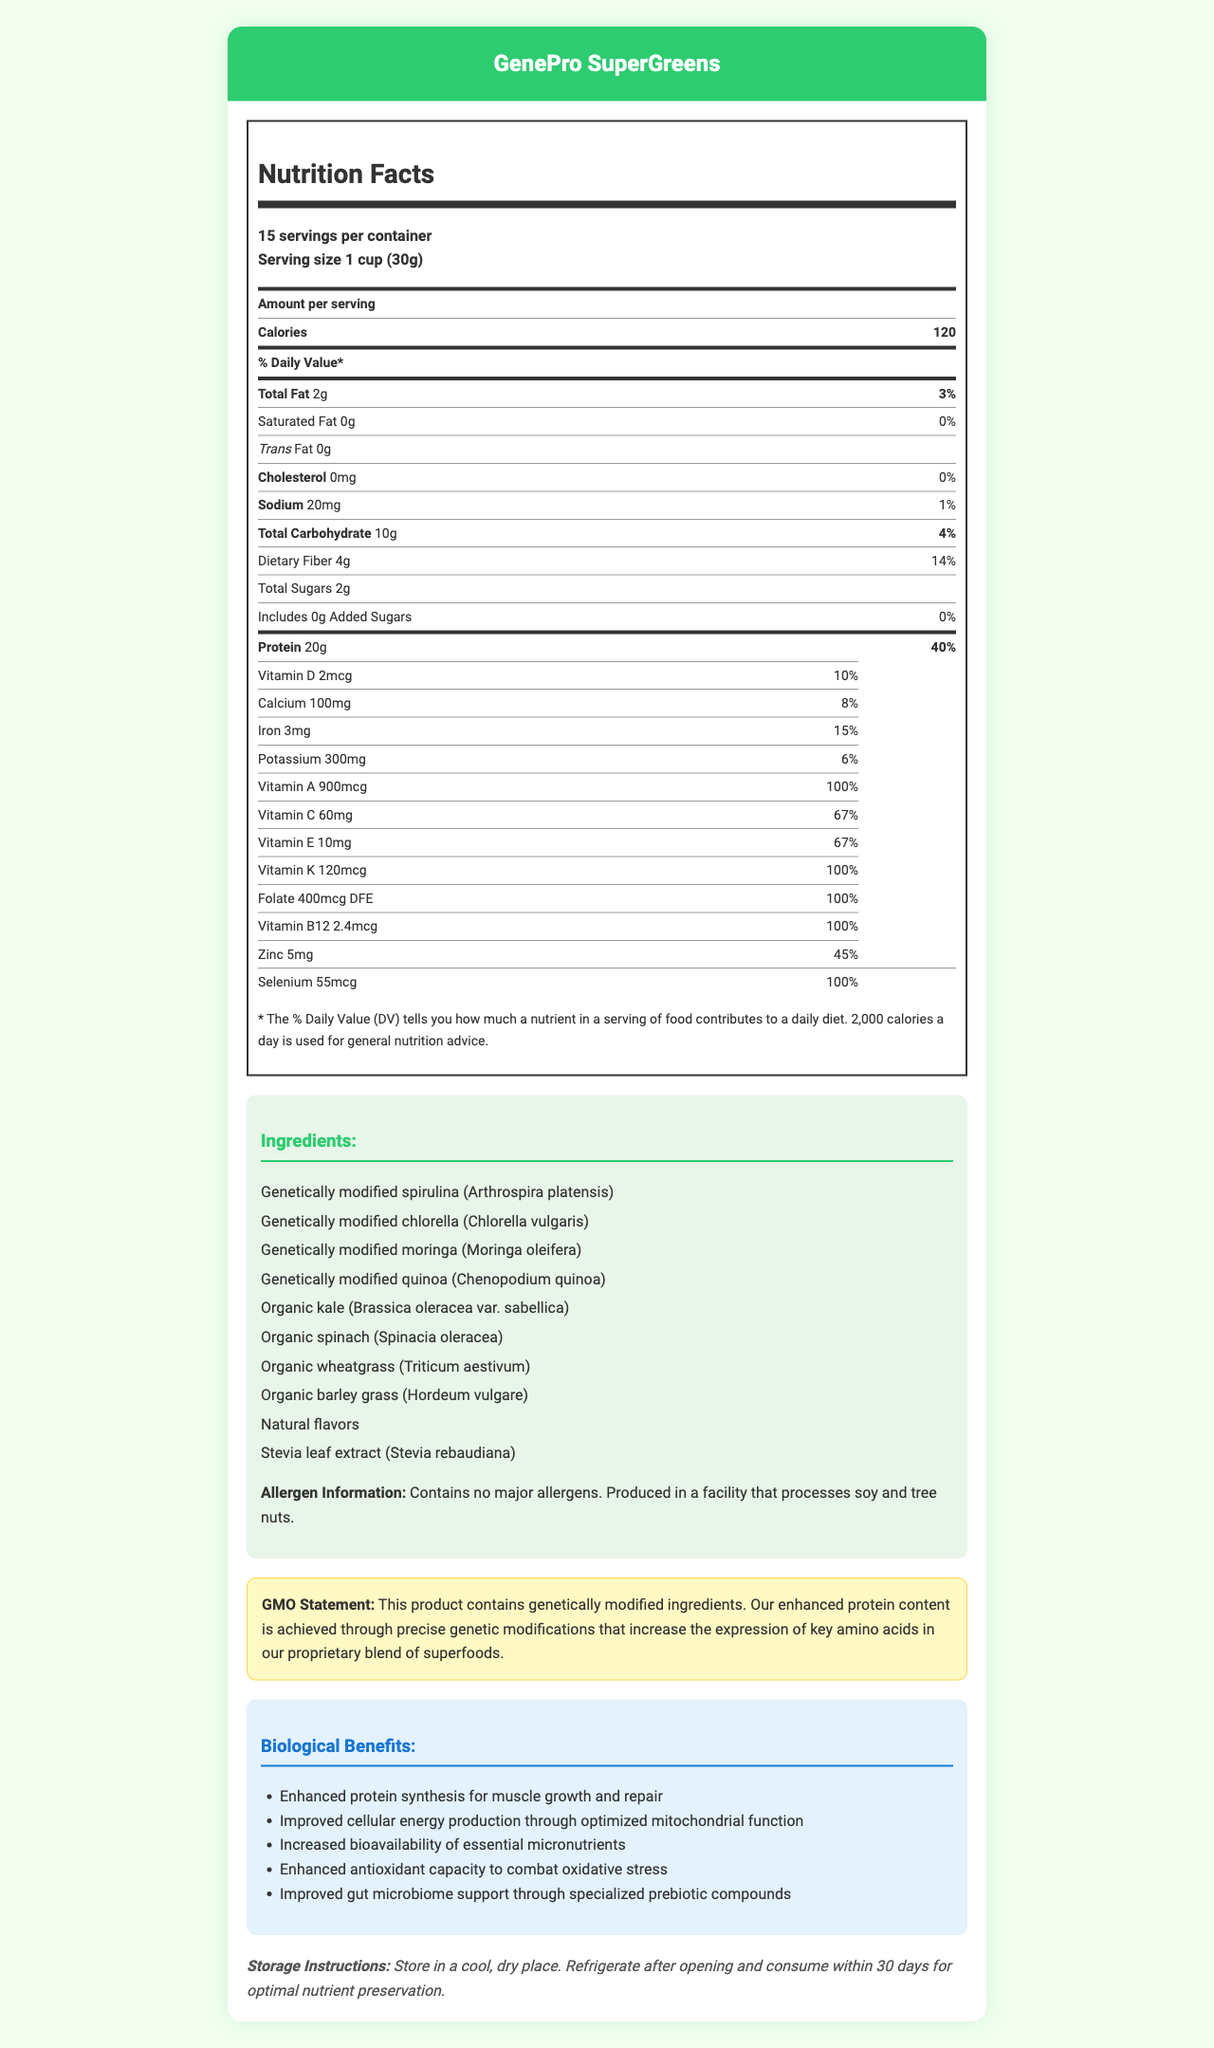what is the serving size of GenePro SuperGreens? The serving size is mentioned right under the product name in the serving details section.
Answer: 1 cup (30g) how many servings are there per container? The number of servings per container is listed just below the serving size.
Answer: 15 how many calories are there per serving? The number of calories per serving is clearly stated under the "Amount per serving" section.
Answer: 120 how much protein does a single serving contain? The protein content per serving, 20g, is listed in the "Amount per serving" section.
Answer: 20g what percent of the daily value for dietary fiber does one serving provide? The percentage of daily value for dietary fiber is specified next to its amount.
Answer: 14% which ingredient is not genetically modified in GenePro SuperGreens? A. Spirulina B. Chlorella C. Kale D. Quinoa The ingredients list specifies that kale is organic and not genetically modified.
Answer: C how much Vitamin A is there in one serving? The amount of Vitamin A per serving is listed in the vitamins and minerals section.
Answer: 900mcg is there any added sugar in GenePro SuperGreens? The added sugars section clearly states that there are 0g of added sugars.
Answer: No, 0g what are the potential biological benefits of consuming GenePro SuperGreens? These benefits are listed under the "Biological Benefits" section.
Answer: Enhanced protein synthesis, improved cellular energy production, increased bioavailability of essential micronutrients, enhanced antioxidant capacity, and improved gut microbiome support is this product suitable for individuals with soy or tree nut allergies? Although the product itself does not contain major allergens, it is produced in a facility that processes soy and tree nuts, as stated in the allergen information.
Answer: No which vitamins and micronutrients in GenePro SuperGreens have 100% daily value per serving? A. Vitamin D B. Vitamin A C. Vitamin C D. Selenium Both Vitamin A and Selenium have 100% daily value per serving as listed in their respective sections.
Answer: B, D how should GenePro SuperGreens be stored after opening? The storage instructions specify that the product should be refrigerated after opening and consumed within 30 days.
Answer: Refrigerate and consume within 30 days to which family does genetically modified moringa belong? The document provides the common name of Moringa but does not specify the family it belongs to, thus this information is not provided.
Answer: Cannot be determined provide a summary of the main aspects of GenePro SuperGreens described in the document. The document highlights various key points including nutritional values, ingredients, allergen information, GMO statement, biological benefits, and storage instructions.
Answer: GenePro SuperGreens is a genetically modified superfood with an enhanced protein content, providing substantial nutritional benefits such as increased bioavailability of key micronutrients and improved antioxidant capacity. The product offers 120 calories per serving with a notable 20g of protein, along with significant amounts of various vitamins and minerals. It has no major allergens but is processed in a facility that handles soy and tree nuts. The ingredients include genetically modified spirulina, chlorella, moringa, and quinoa, along with several organic components. The product should be stored in a cool, dry place and refrigerated after opening for optimal nutrient preservation. 